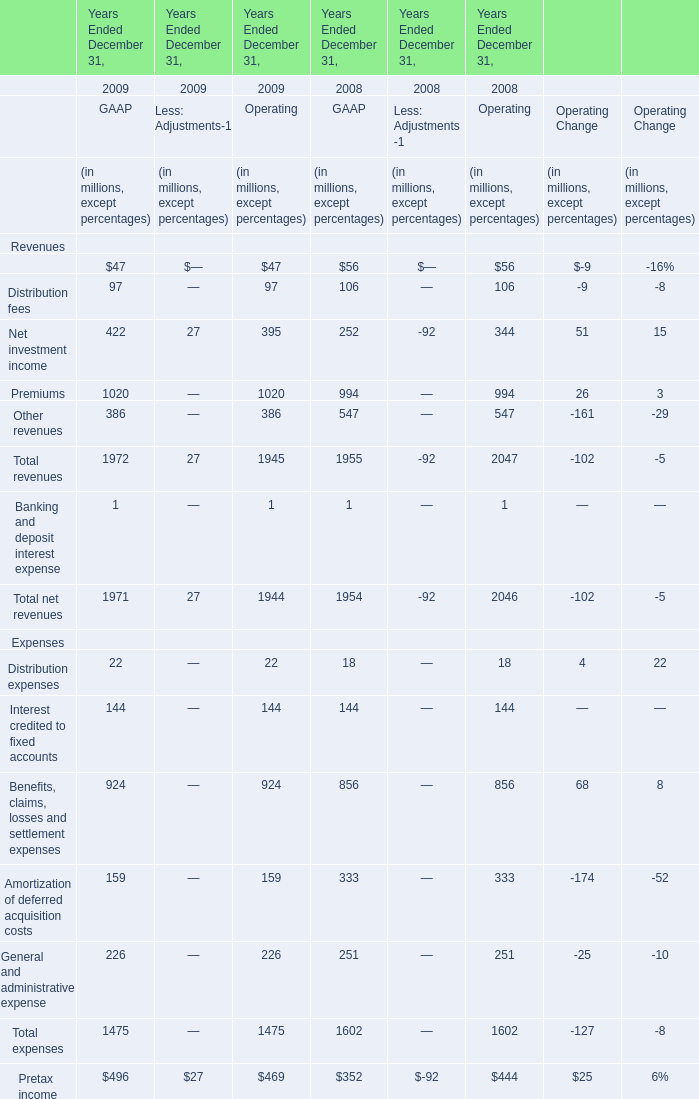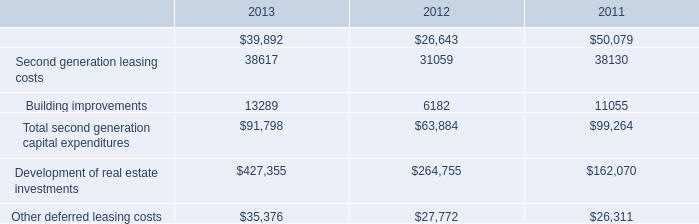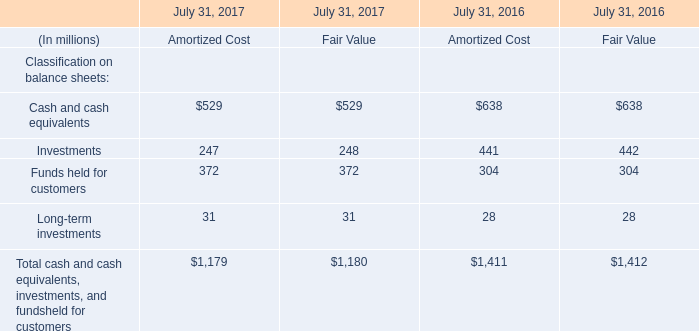what was the percentage change in the second generation tenant improvements from 2012 to 2013 
Computations: ((39892 - 26643) / 26643)
Answer: 0.49728. 